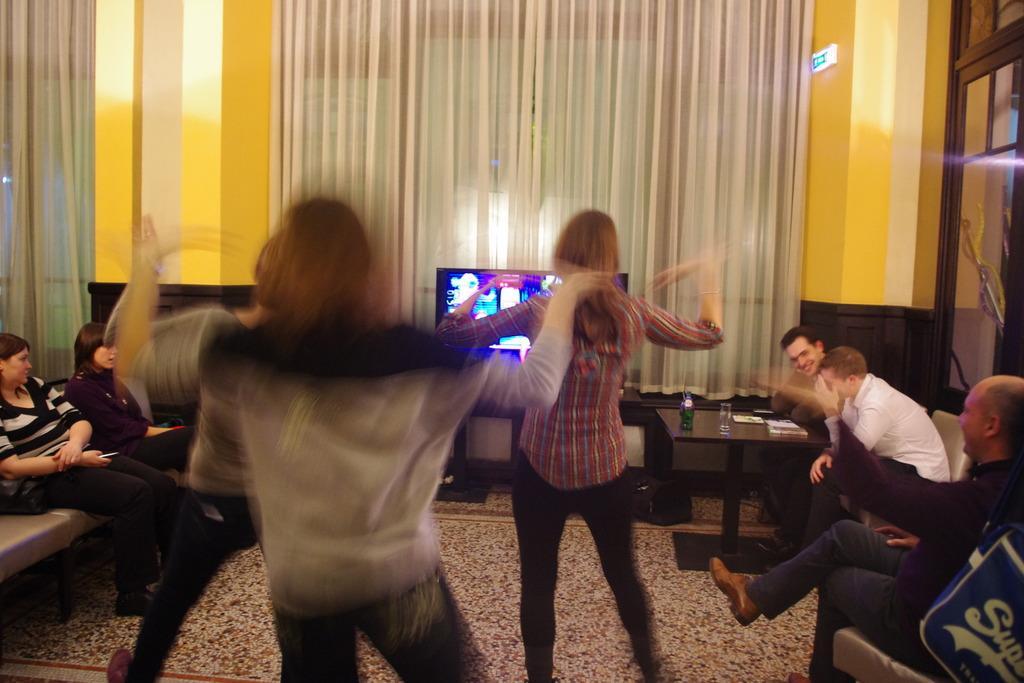Can you describe this image briefly? In the picture I can see some people are sitting on the couch, some people are dancing, in front there is a television, curtain and doors to the wall. 